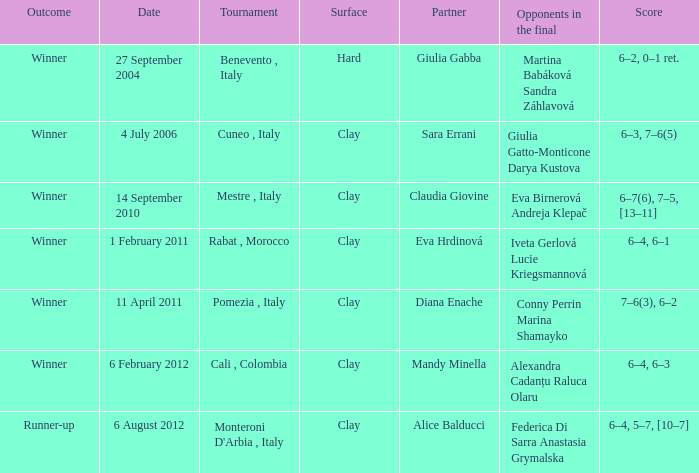Write the full table. {'header': ['Outcome', 'Date', 'Tournament', 'Surface', 'Partner', 'Opponents in the final', 'Score'], 'rows': [['Winner', '27 September 2004', 'Benevento , Italy', 'Hard', 'Giulia Gabba', 'Martina Babáková Sandra Záhlavová', '6–2, 0–1 ret.'], ['Winner', '4 July 2006', 'Cuneo , Italy', 'Clay', 'Sara Errani', 'Giulia Gatto-Monticone Darya Kustova', '6–3, 7–6(5)'], ['Winner', '14 September 2010', 'Mestre , Italy', 'Clay', 'Claudia Giovine', 'Eva Birnerová Andreja Klepač', '6–7(6), 7–5, [13–11]'], ['Winner', '1 February 2011', 'Rabat , Morocco', 'Clay', 'Eva Hrdinová', 'Iveta Gerlová Lucie Kriegsmannová', '6–4, 6–1'], ['Winner', '11 April 2011', 'Pomezia , Italy', 'Clay', 'Diana Enache', 'Conny Perrin Marina Shamayko', '7–6(3), 6–2'], ['Winner', '6 February 2012', 'Cali , Colombia', 'Clay', 'Mandy Minella', 'Alexandra Cadanțu Raluca Olaru', '6–4, 6–3'], ['Runner-up', '6 August 2012', "Monteroni D'Arbia , Italy", 'Clay', 'Alice Balducci', 'Federica Di Sarra Anastasia Grymalska', '6–4, 5–7, [10–7]']]} Who participated on a tough surface? Giulia Gabba. 